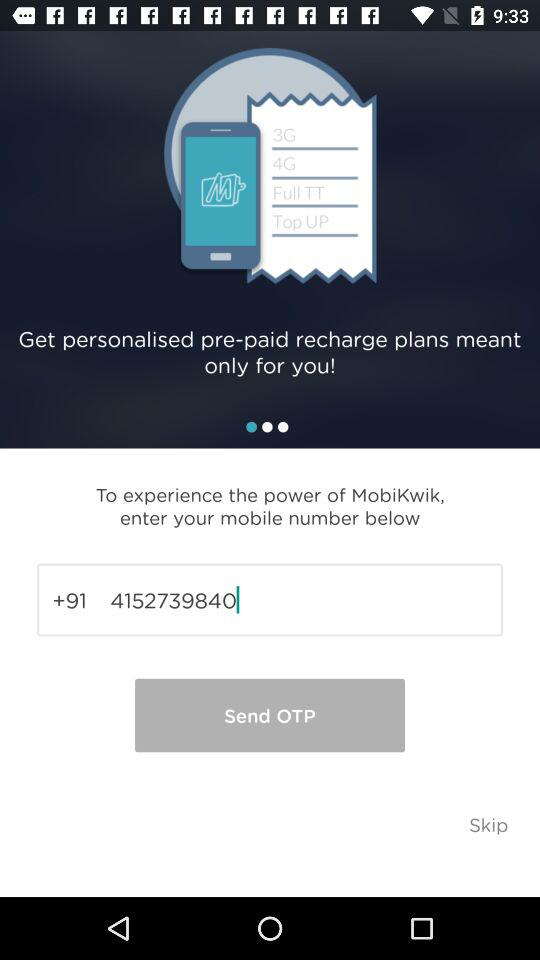What is the application name? The application name is "MobiKwik". 